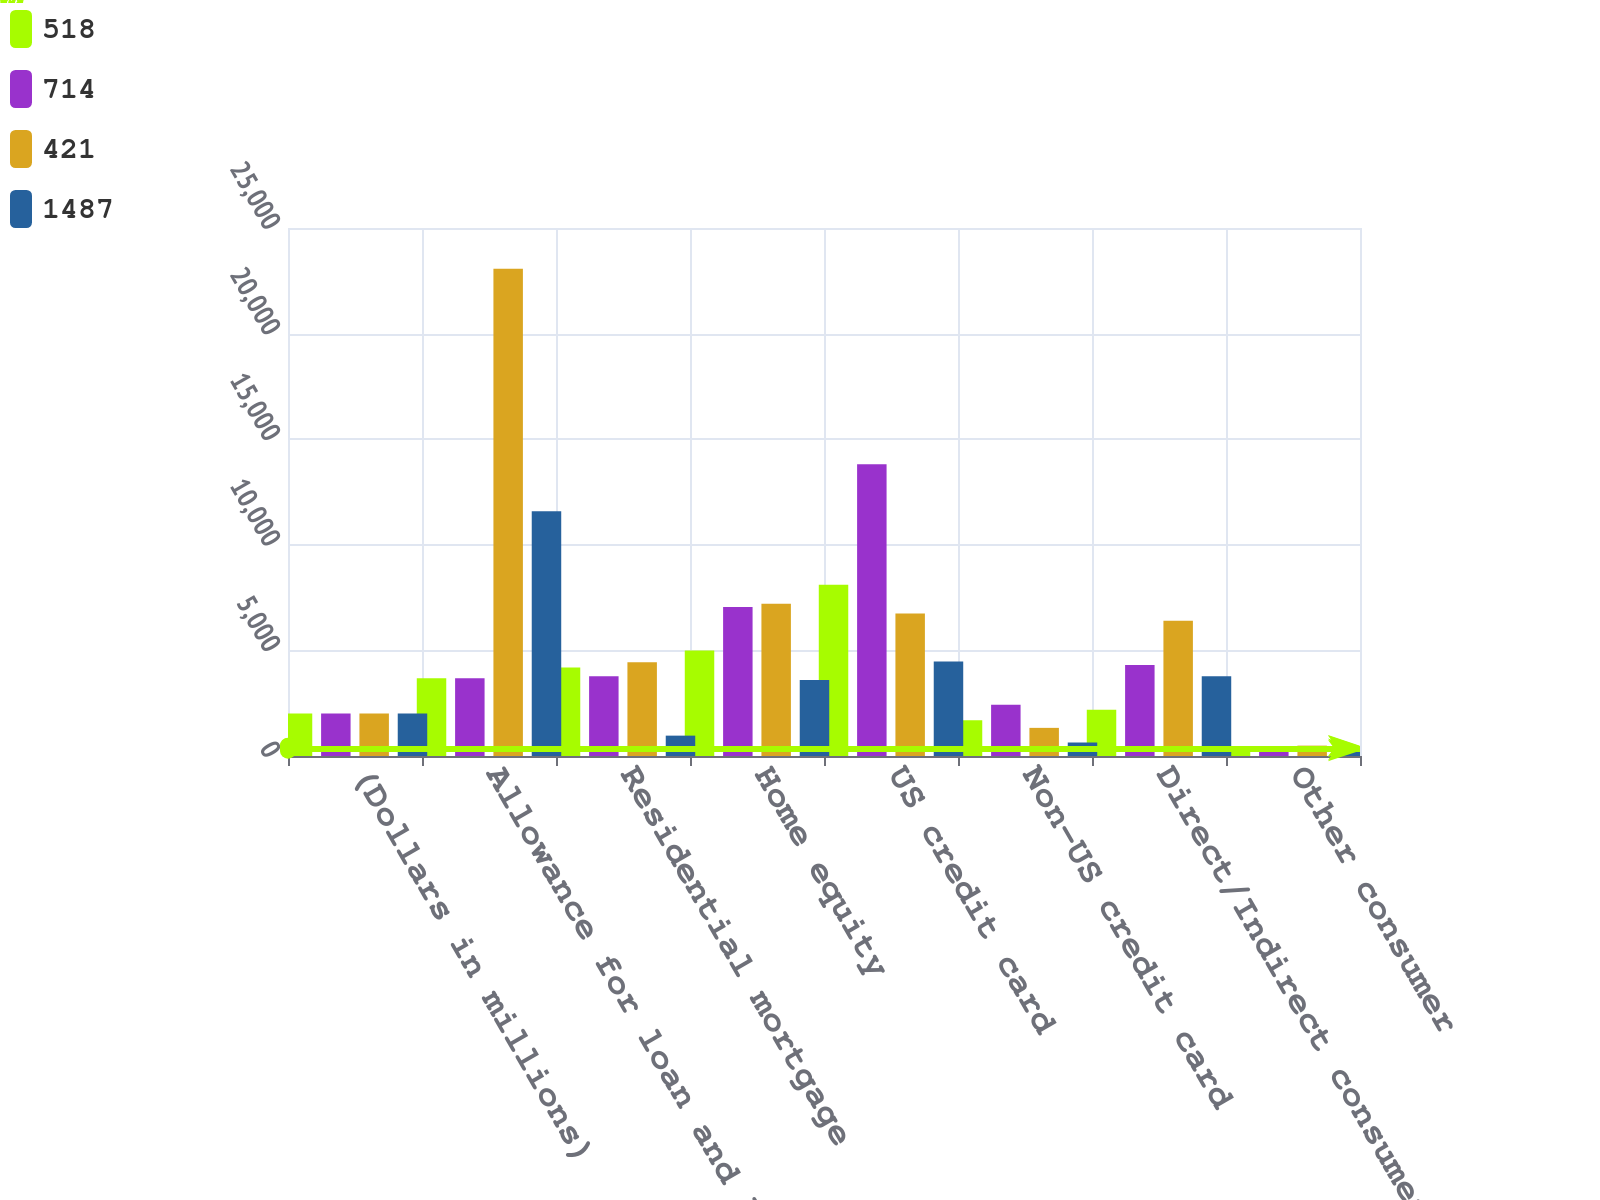Convert chart to OTSL. <chart><loc_0><loc_0><loc_500><loc_500><stacked_bar_chart><ecel><fcel>(Dollars in millions)<fcel>Allowance for loan and lease<fcel>Residential mortgage<fcel>Home equity<fcel>US credit card<fcel>Non-US credit card<fcel>Direct/Indirect consumer<fcel>Other consumer<nl><fcel>518<fcel>2011<fcel>3687<fcel>4195<fcel>4990<fcel>8114<fcel>1691<fcel>2190<fcel>252<nl><fcel>714<fcel>2010<fcel>3687<fcel>3779<fcel>7059<fcel>13818<fcel>2424<fcel>4303<fcel>320<nl><fcel>421<fcel>2009<fcel>23071<fcel>4436<fcel>7205<fcel>6753<fcel>1332<fcel>6406<fcel>491<nl><fcel>1487<fcel>2008<fcel>11588<fcel>964<fcel>3597<fcel>4469<fcel>639<fcel>3777<fcel>461<nl></chart> 